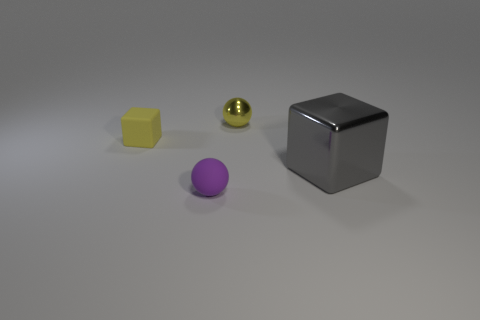Is there any other thing that has the same size as the gray cube?
Your answer should be compact. No. What shape is the yellow thing that is the same material as the small purple sphere?
Offer a very short reply. Cube. What is the color of the block right of the small matte object in front of the shiny cube that is right of the small yellow block?
Keep it short and to the point. Gray. Are there an equal number of large gray metal cubes that are in front of the big gray cube and big purple rubber cylinders?
Offer a terse response. Yes. Is there any other thing that has the same material as the tiny purple object?
Provide a succinct answer. Yes. There is a small metallic thing; is its color the same as the metal thing that is in front of the yellow matte object?
Your answer should be very brief. No. Is there a small purple ball that is behind the metallic thing in front of the block behind the big object?
Keep it short and to the point. No. Are there fewer small matte balls in front of the rubber sphere than things?
Your answer should be compact. Yes. How many other objects are there of the same shape as the tiny metallic object?
Provide a short and direct response. 1. How many objects are small rubber objects that are behind the large gray shiny cube or small things to the right of the small purple thing?
Keep it short and to the point. 2. 